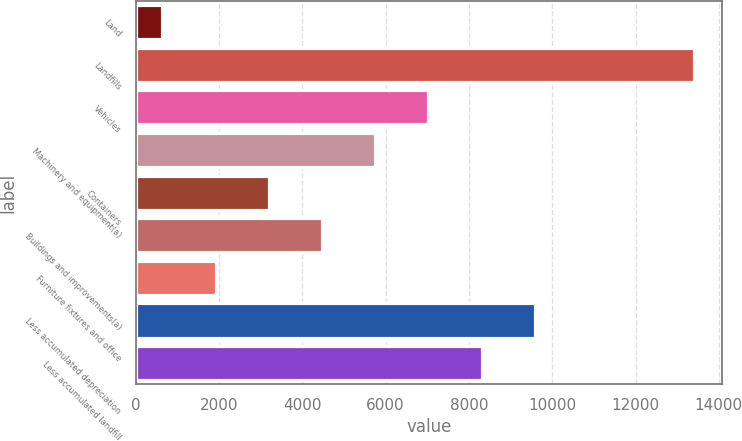Convert chart. <chart><loc_0><loc_0><loc_500><loc_500><bar_chart><fcel>Land<fcel>Landfills<fcel>Vehicles<fcel>Machinery and equipment(a)<fcel>Containers<fcel>Buildings and improvements(a)<fcel>Furniture fixtures and office<fcel>Less accumulated depreciation<fcel>Less accumulated landfill<nl><fcel>636<fcel>13416<fcel>7026<fcel>5748<fcel>3192<fcel>4470<fcel>1914<fcel>9582<fcel>8304<nl></chart> 